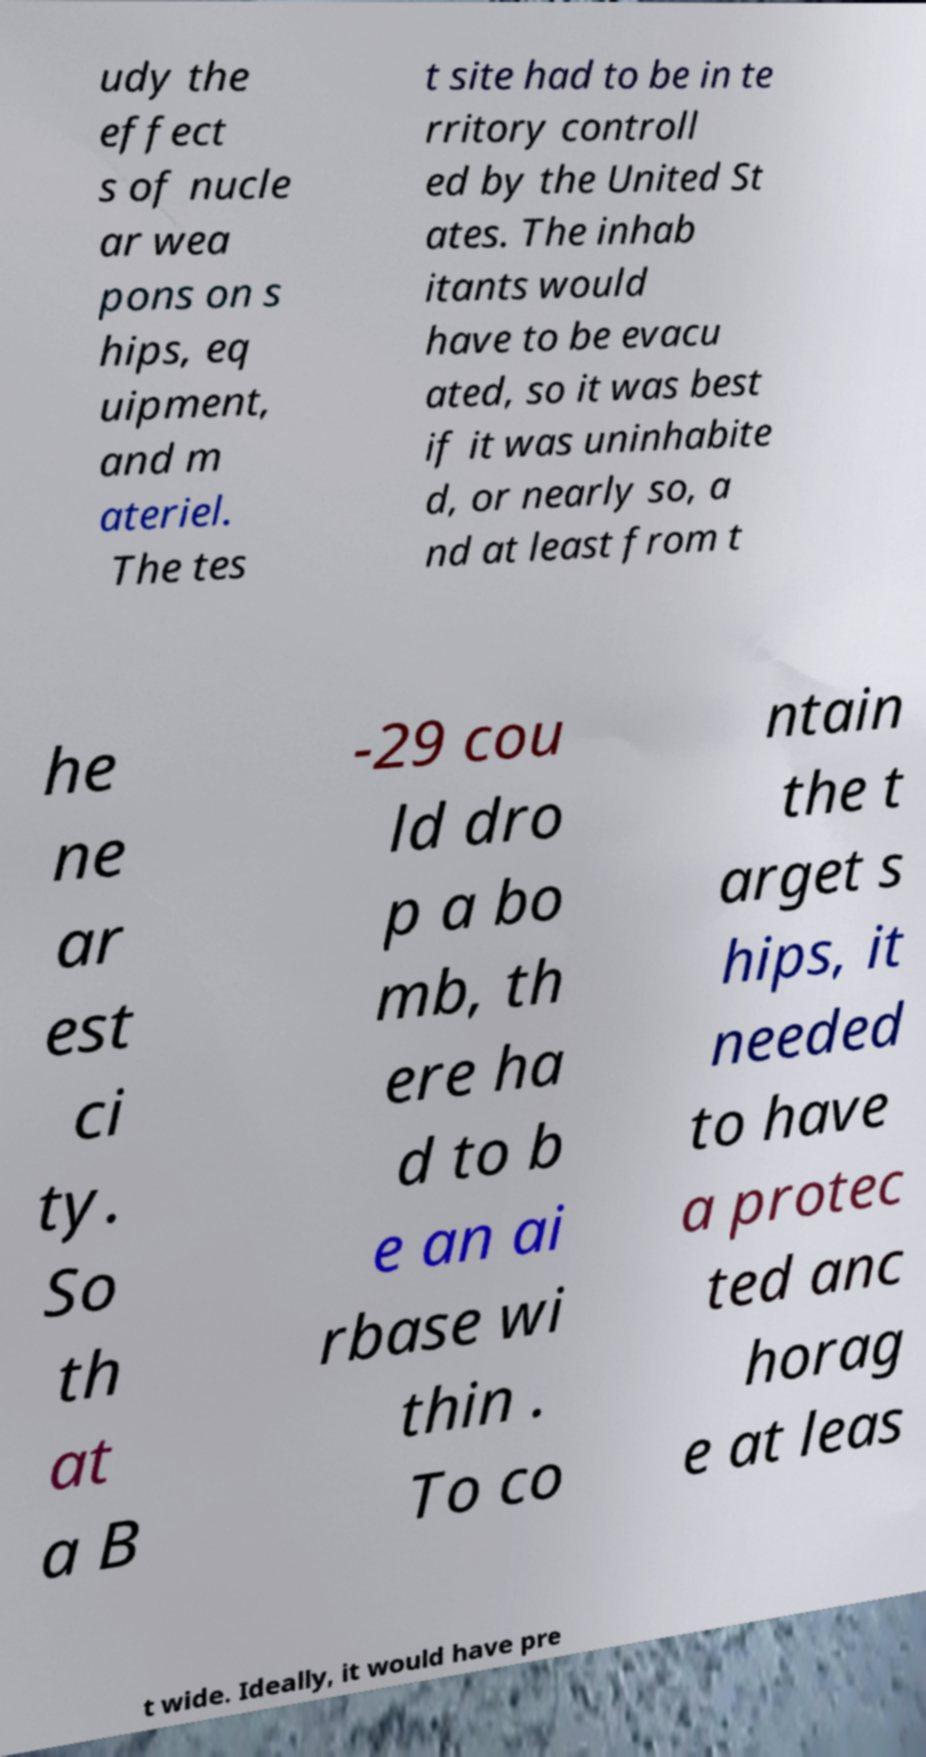Please read and relay the text visible in this image. What does it say? udy the effect s of nucle ar wea pons on s hips, eq uipment, and m ateriel. The tes t site had to be in te rritory controll ed by the United St ates. The inhab itants would have to be evacu ated, so it was best if it was uninhabite d, or nearly so, a nd at least from t he ne ar est ci ty. So th at a B -29 cou ld dro p a bo mb, th ere ha d to b e an ai rbase wi thin . To co ntain the t arget s hips, it needed to have a protec ted anc horag e at leas t wide. Ideally, it would have pre 